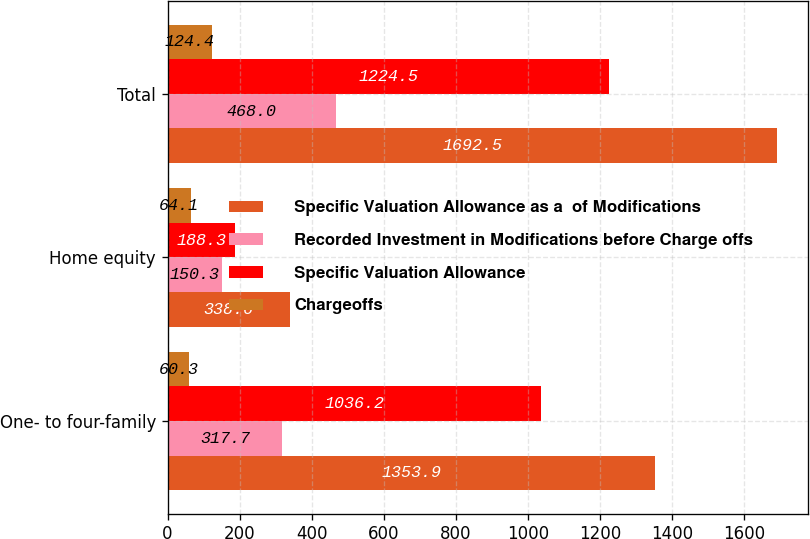<chart> <loc_0><loc_0><loc_500><loc_500><stacked_bar_chart><ecel><fcel>One- to four-family<fcel>Home equity<fcel>Total<nl><fcel>Specific Valuation Allowance as a  of Modifications<fcel>1353.9<fcel>338.6<fcel>1692.5<nl><fcel>Recorded Investment in Modifications before Charge offs<fcel>317.7<fcel>150.3<fcel>468<nl><fcel>Specific Valuation Allowance<fcel>1036.2<fcel>188.3<fcel>1224.5<nl><fcel>Chargeoffs<fcel>60.3<fcel>64.1<fcel>124.4<nl></chart> 